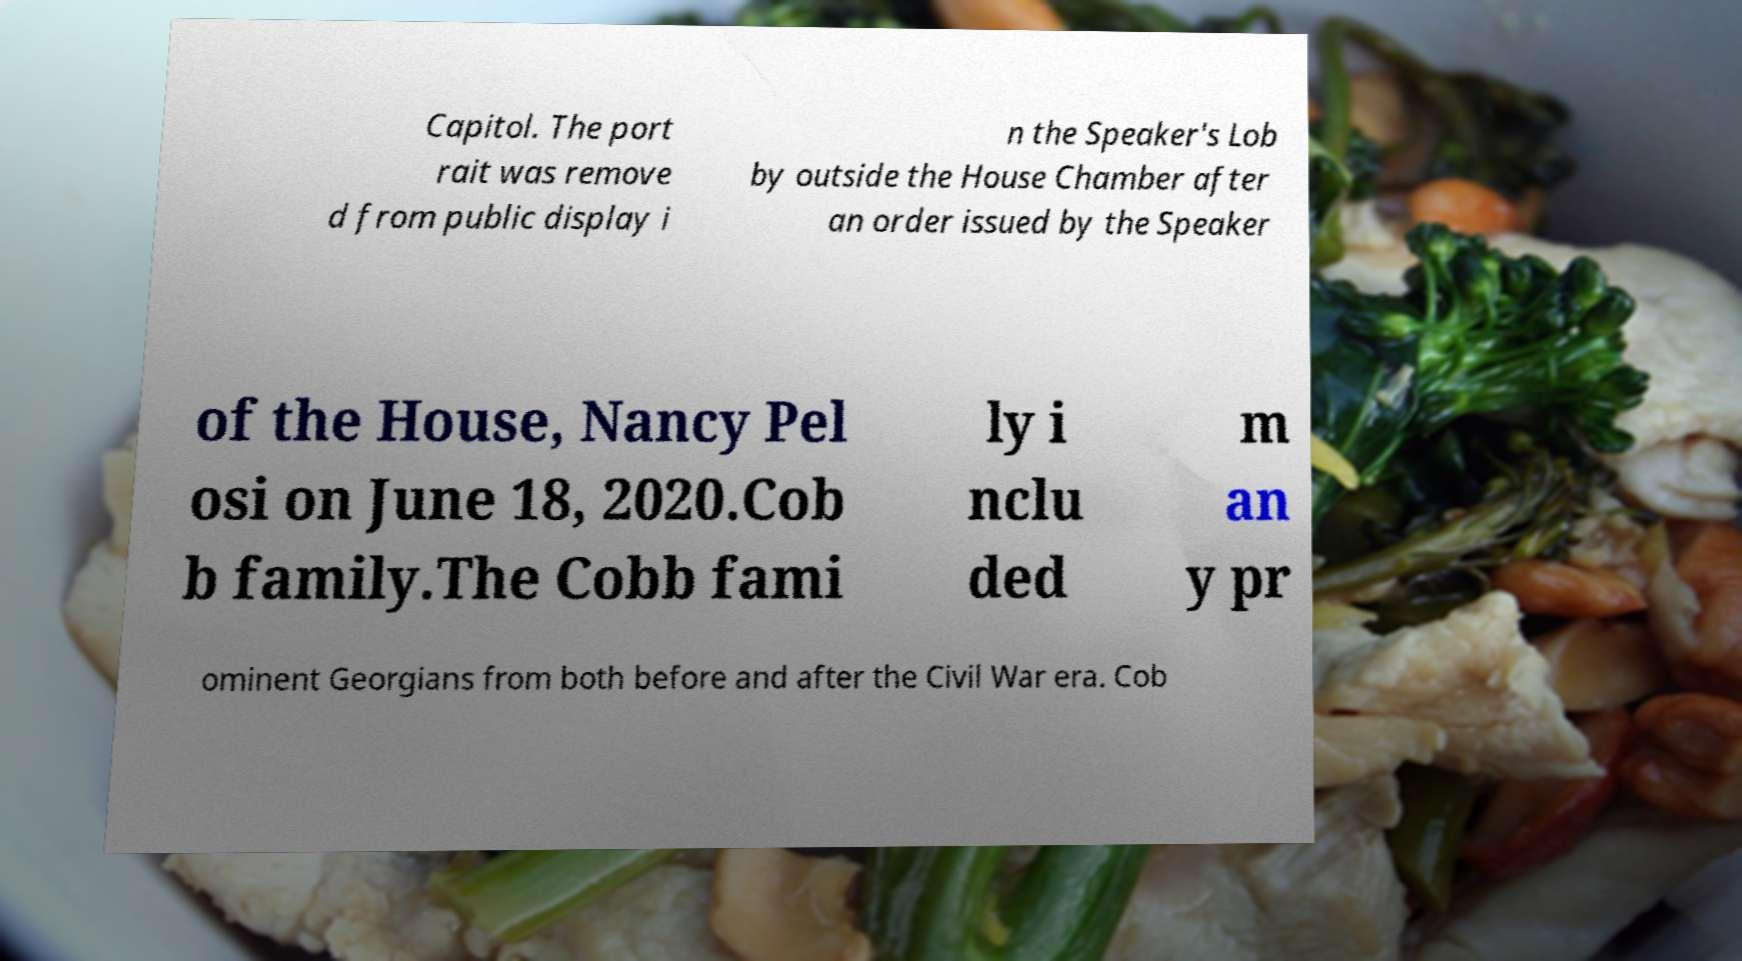Could you assist in decoding the text presented in this image and type it out clearly? Capitol. The port rait was remove d from public display i n the Speaker's Lob by outside the House Chamber after an order issued by the Speaker of the House, Nancy Pel osi on June 18, 2020.Cob b family.The Cobb fami ly i nclu ded m an y pr ominent Georgians from both before and after the Civil War era. Cob 